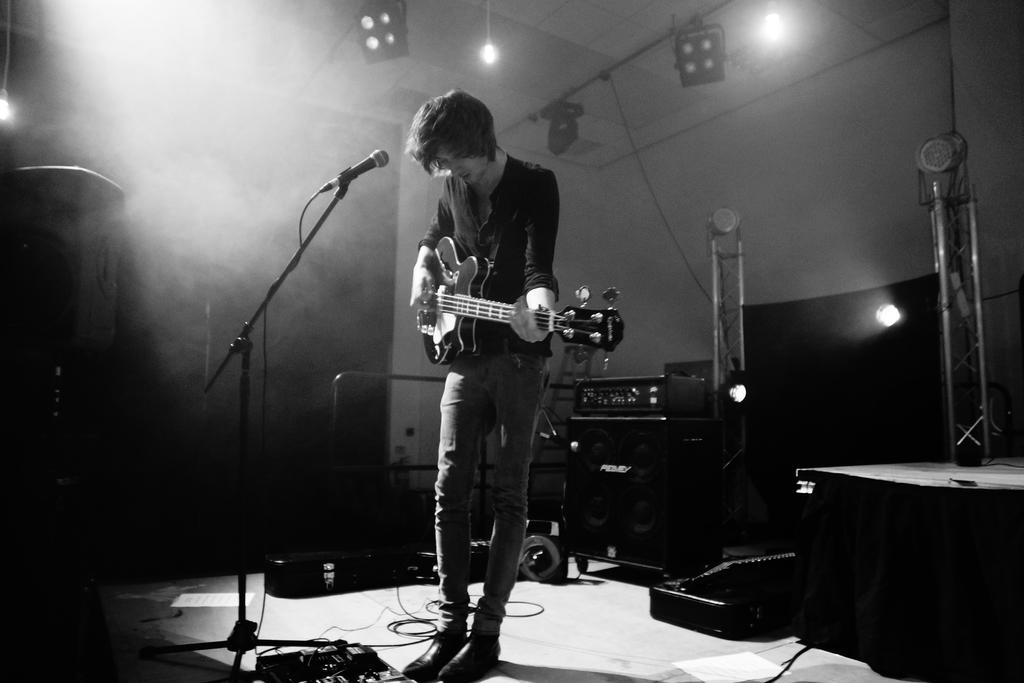What is the color scheme of the image? The image is black and white. Who is the person in the image? There is a man in the image. What is the man doing in the image? The man is playing a guitar. What is the man using to amplify his sound? There is a microphone in front of the man. What can be seen in the background of the image? There are lights visible in the image. What is the man likely performing in front of? There is a sound box in the image, suggesting that the man is performing in front of an audience. What type of suit is the man wearing in the image? There is no suit visible in the image; the man is wearing a shirt and pants. What time does the man's watch show in the image? There is no watch visible in the image. 